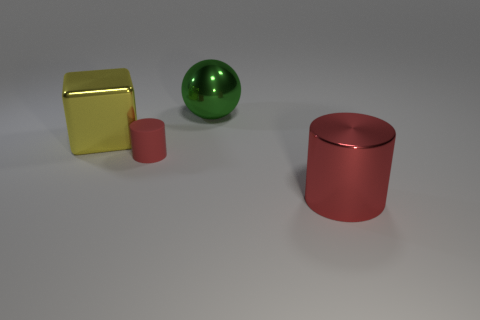Is there any other thing that has the same size as the red matte cylinder?
Provide a short and direct response. No. Are there any other things that are the same material as the tiny red thing?
Provide a succinct answer. No. What size is the thing that is the same color as the large cylinder?
Give a very brief answer. Small. Do the metallic object that is in front of the small red cylinder and the big green object have the same shape?
Make the answer very short. No. Is the number of cylinders that are to the right of the large green object greater than the number of large green metal balls on the left side of the small red matte object?
Give a very brief answer. Yes. What number of big objects are in front of the matte cylinder in front of the big green shiny object?
Your answer should be very brief. 1. There is a object that is the same color as the big cylinder; what material is it?
Offer a terse response. Rubber. What number of other objects are the same color as the big metallic cylinder?
Provide a short and direct response. 1. The metal thing that is in front of the red cylinder left of the green metallic thing is what color?
Keep it short and to the point. Red. Are there any big metallic things that have the same color as the small thing?
Ensure brevity in your answer.  Yes. 